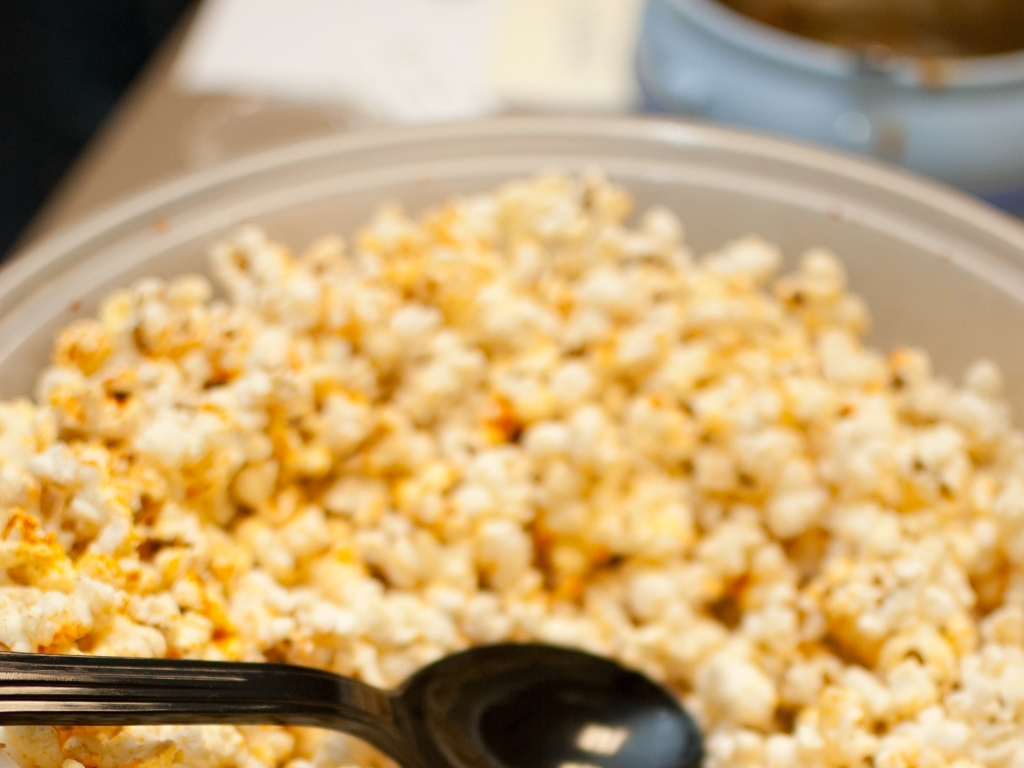Is this a healthy snack option? Popcorn can be a healthy snack if it's air-popped and minimally seasoned. However, the popcorn in this image appears to be coated with seasoning, which might add extra calories or sodium, potentially making it less healthy than plain popcorn. 